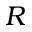<formula> <loc_0><loc_0><loc_500><loc_500>R</formula> 